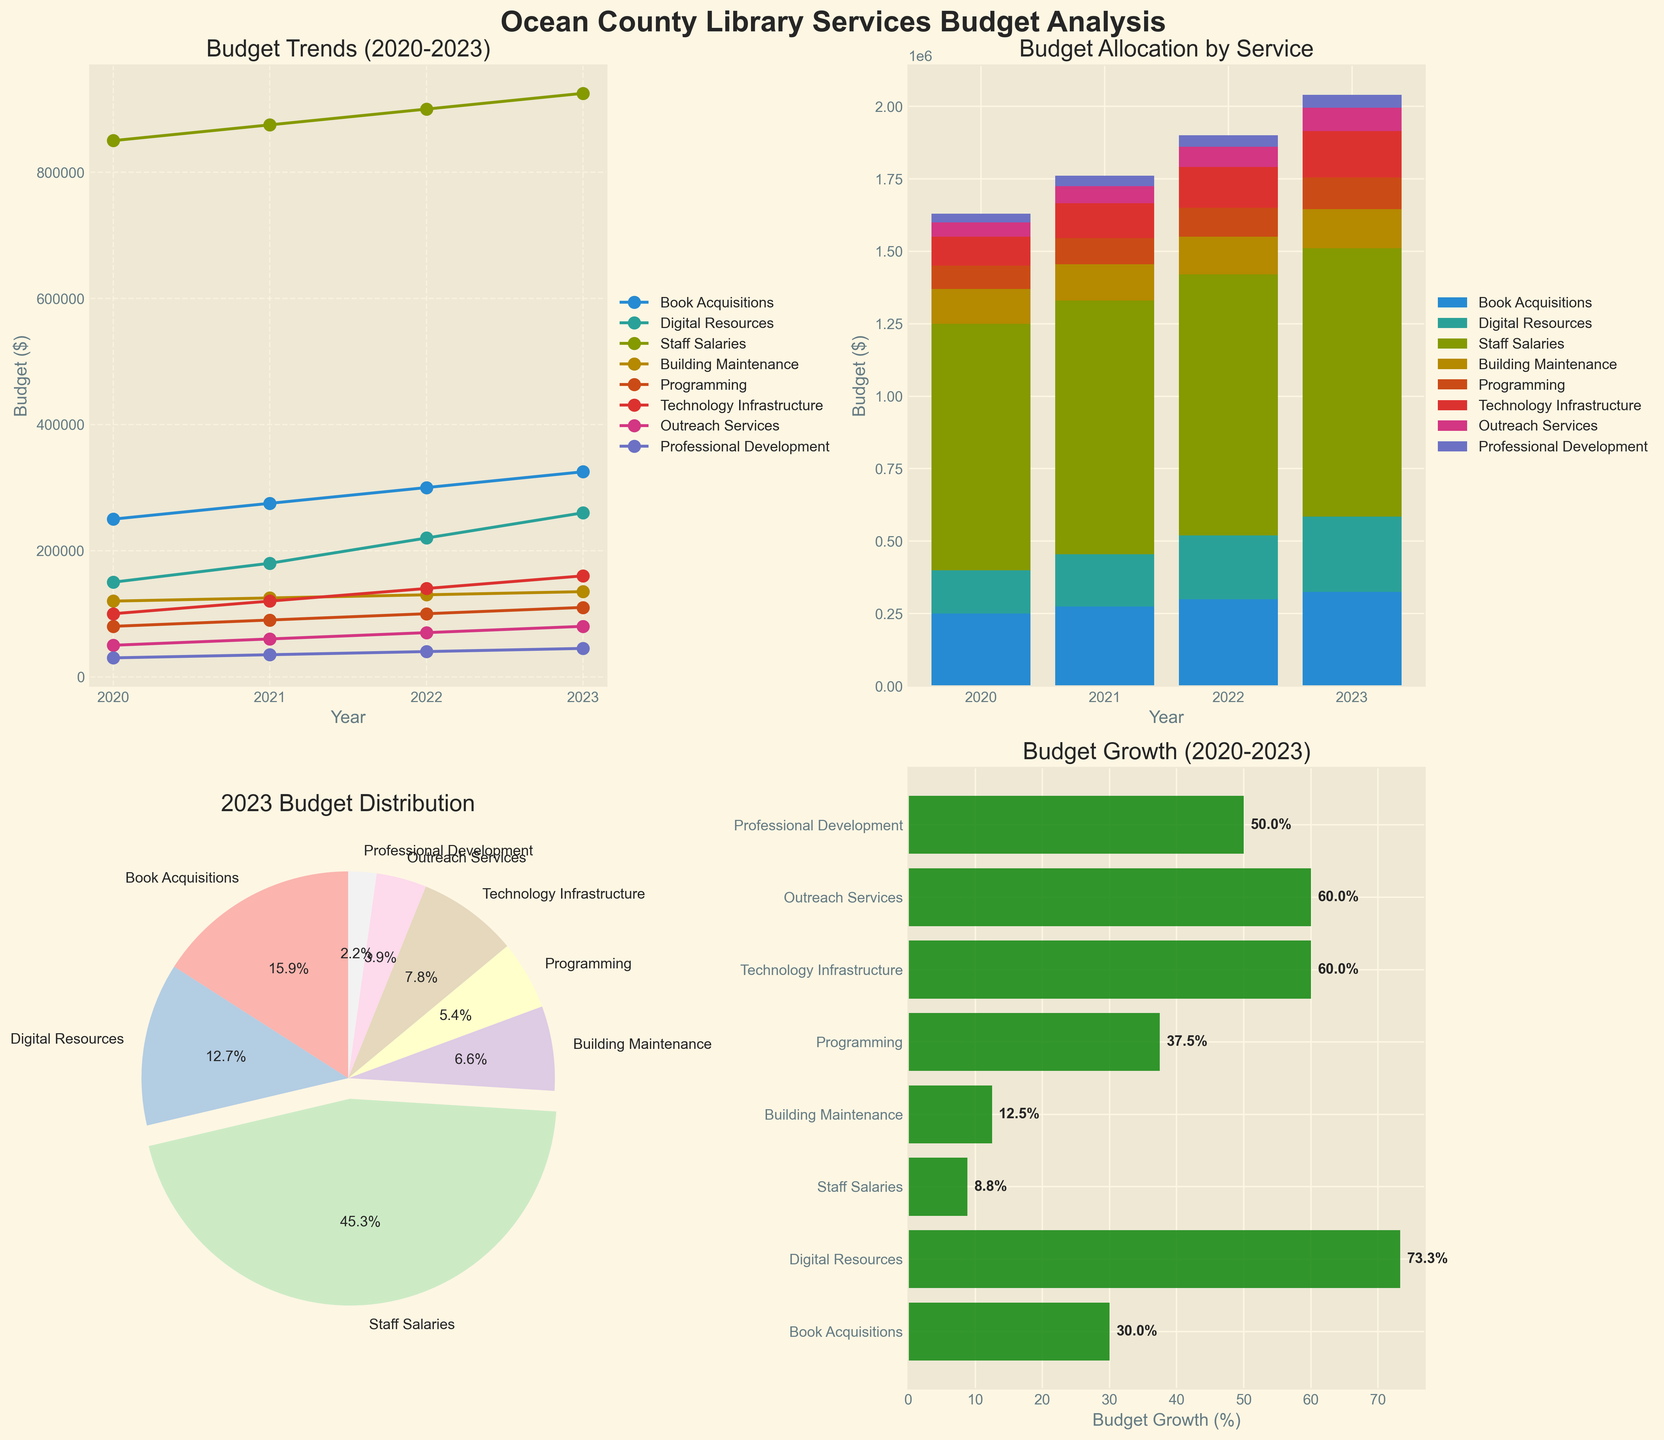what is the title of subplot (top-left)? The title is written at the top of the specific subplot (top-left corner), and it reads 'Budget Trends (2020-2023)'.
Answer: Budget Trends (2020-2023) How much of the 2023 budget is allocated to technology infrastructure? In the pie chart subplot (bottom-left), find the slice labeled "Technology Infrastructure" and look at the percentage allocated. The label "Technology Infrastructure" shows 7.1%.
Answer: 7.1% Which service had the most significant budget allocation in 2023? The pie chart subplot (bottom-left) shows the 2023 budget distribution. The biggest slice is labeled "Staff Salaries", representing 61.5%.
Answer: Staff Salaries What is the total budget for 'Programming' from 2020 to 2023? To calculate, sum all the values for Programming service across the years: 80,000 + 90,000 + 100,000 + 110,000 = 380,000.
Answer: 380,000 Which service had the highest budget growth percentage from 2020 to 2023? In the horizontal bar plot subplot (bottom-right), the longest bar indicates the highest percentage. 'Digital Resources' shows 73.3%.
Answer: Digital Resources What trend is observed in the 'Building Maintenance' budget from 2020 to 2023? In the line plot subplot (top-left), locate the line for 'Building Maintenance' and observe that it has a consistent increase each year.
Answer: Increasing Compare the 2023 budget allocation for 'Outreach Services' and 'Professional Development'. Which is higher? In the pie chart subplot (bottom-left), compare the slices for 'Outreach Services' (5.3%) and 'Professional Development' (3.0%). 'Outreach Services' has a higher allocation.
Answer: Outreach Services Which service showed the least percentage growth from 2020 to 2023? In the horizontal bar plot subplot (bottom-right), the shortest bar represents the lowest percentage. 'Building Maintenance' shows the least growth with 12.5%.
Answer: Building Maintenance How has the budget for 'Digital Resources' changed from 2020 to 2023? In the line plot subplot (top-left), look at the line for 'Digital Resources'. The budget has increased from 150,000 in 2020 to 260,000 in 2023.
Answer: Increased 